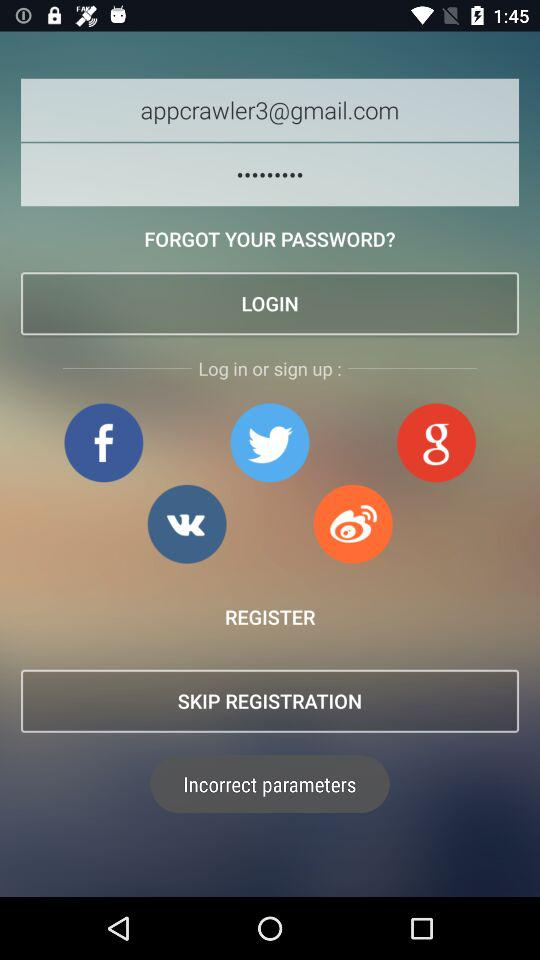What are the options for register?
When the provided information is insufficient, respond with <no answer>. <no answer> 